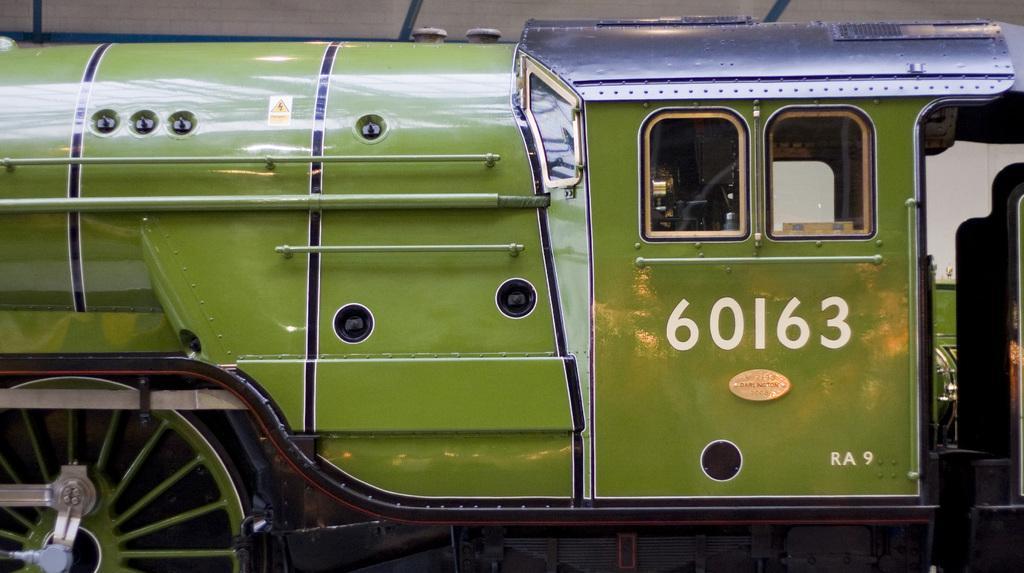Describe this image in one or two sentences. In this image there is a train. The train is in green color. There is some number on the train. There is a wheel on the left bottom. There is a person on the right side. There are windows. 